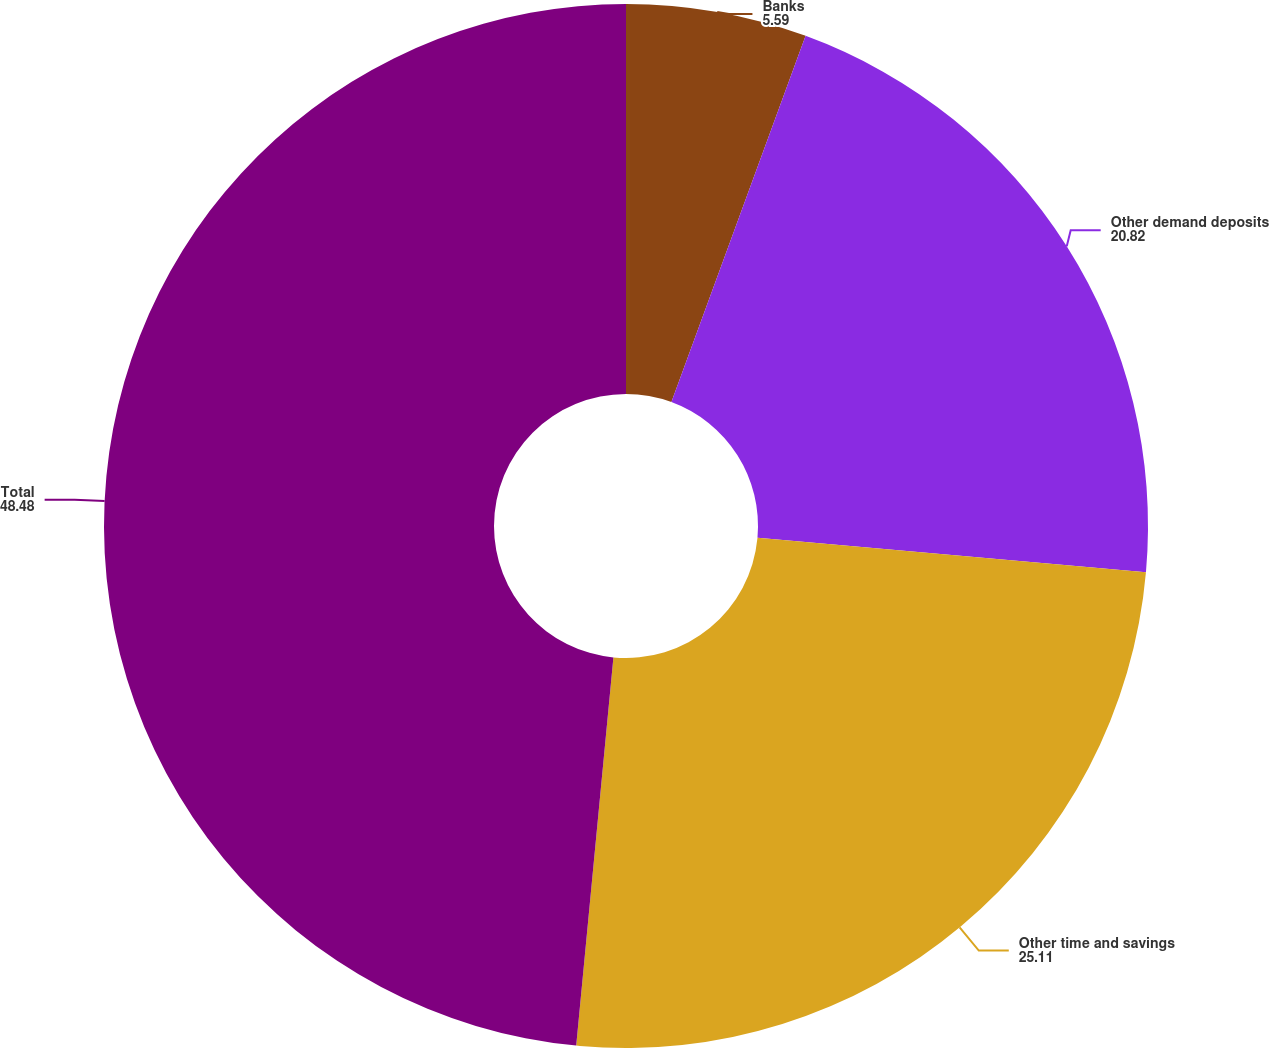<chart> <loc_0><loc_0><loc_500><loc_500><pie_chart><fcel>Banks<fcel>Other demand deposits<fcel>Other time and savings<fcel>Total<nl><fcel>5.59%<fcel>20.82%<fcel>25.11%<fcel>48.48%<nl></chart> 